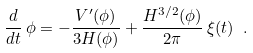Convert formula to latex. <formula><loc_0><loc_0><loc_500><loc_500>\frac { d } { d t } \, \phi = - \frac { V ^ { \prime } ( \phi ) } { 3 H ( \phi ) } + \frac { H ^ { 3 / 2 } ( \phi ) } { 2 \pi } \, \xi ( t ) \ .</formula> 